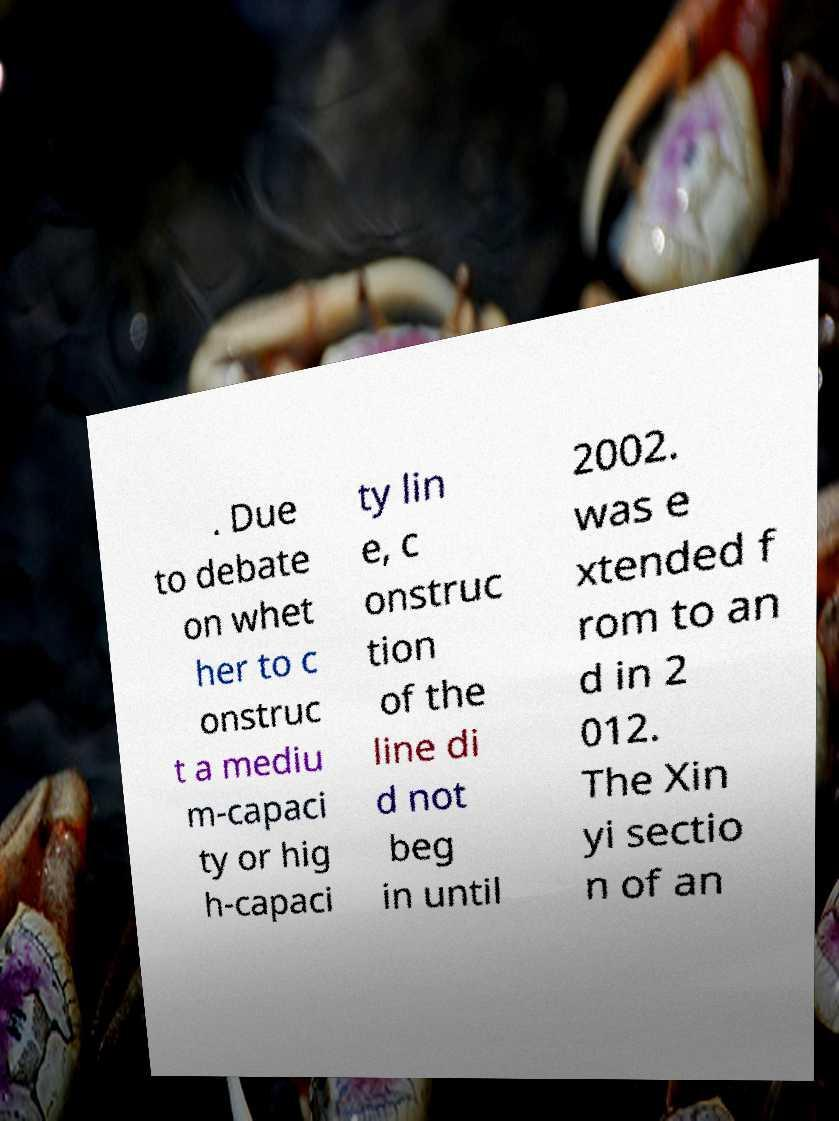Please read and relay the text visible in this image. What does it say? . Due to debate on whet her to c onstruc t a mediu m-capaci ty or hig h-capaci ty lin e, c onstruc tion of the line di d not beg in until 2002. was e xtended f rom to an d in 2 012. The Xin yi sectio n of an 